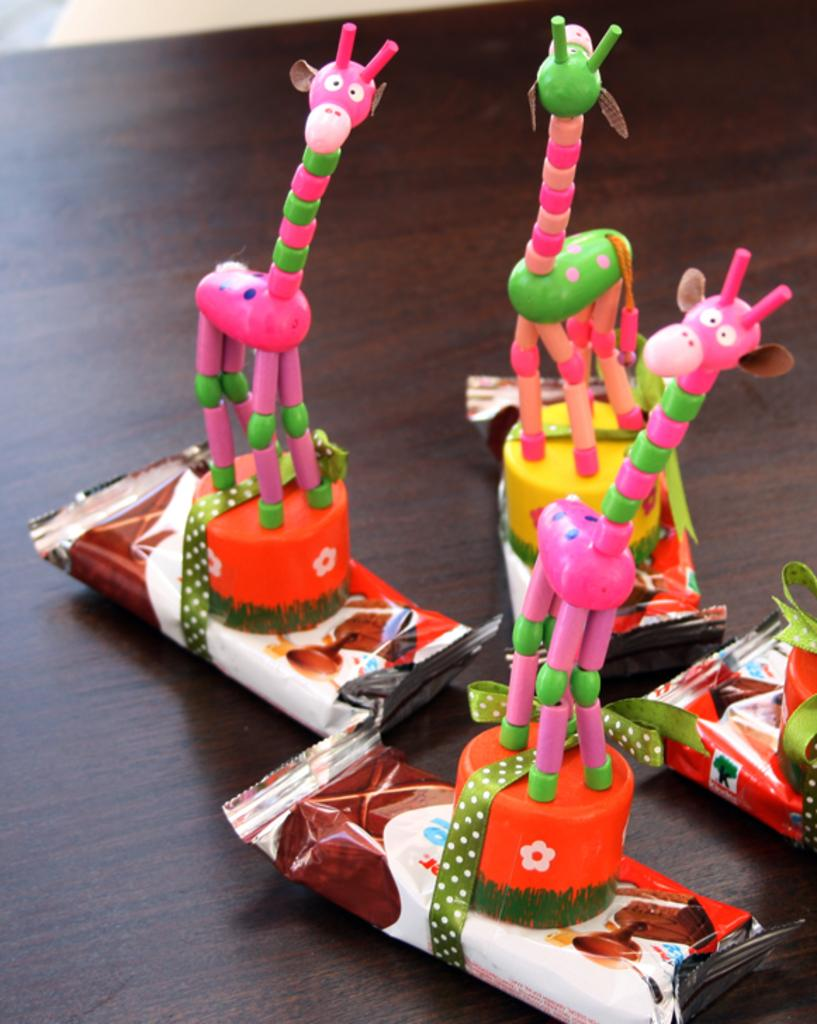What type of food is present on the table in the image? There are chocolates on the table. What else can be seen on the table besides the chocolates? There are toys on the table. What type of smile can be seen on the face of the toy soldier in the image? There is no toy soldier with a smile present in the image; the provided facts only mention chocolates and toys on the table. 